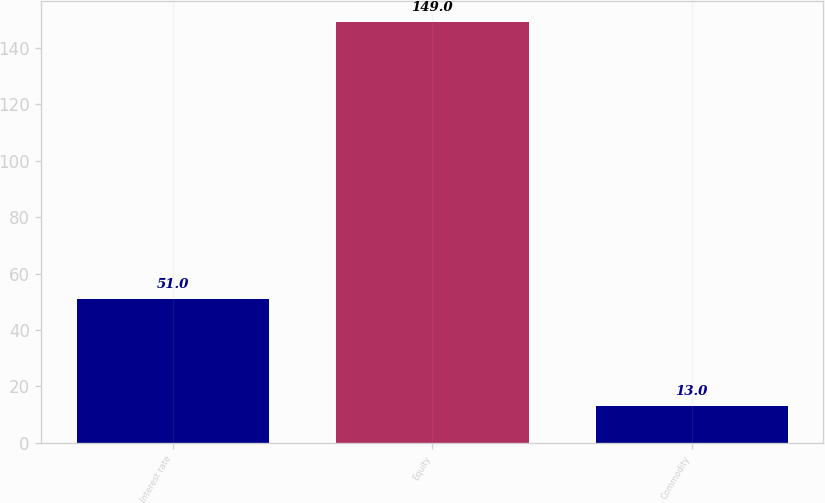<chart> <loc_0><loc_0><loc_500><loc_500><bar_chart><fcel>Interest rate<fcel>Equity<fcel>Commodity<nl><fcel>51<fcel>149<fcel>13<nl></chart> 